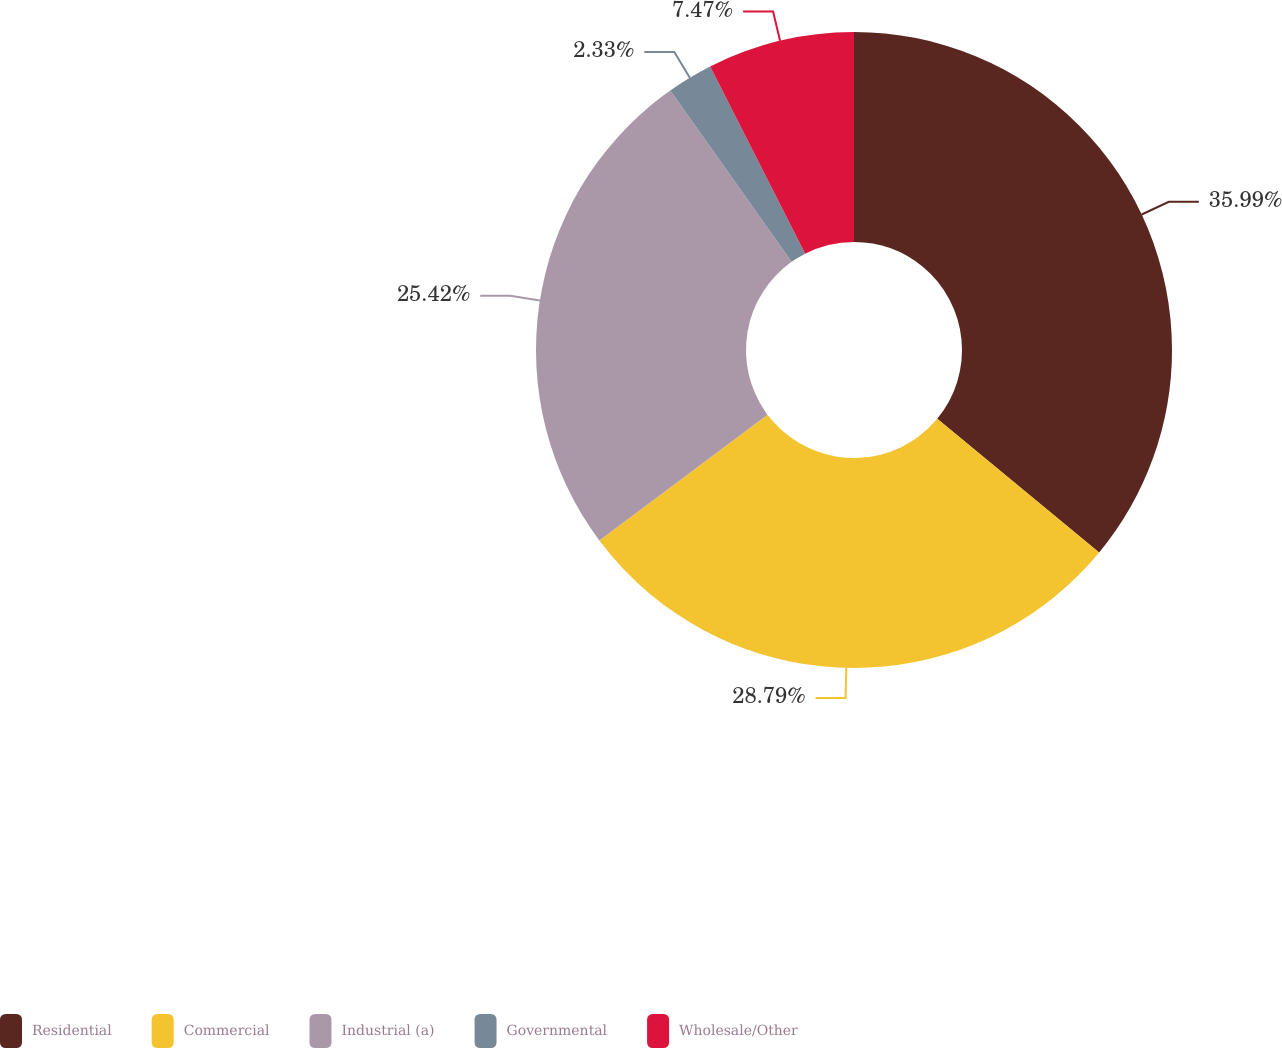<chart> <loc_0><loc_0><loc_500><loc_500><pie_chart><fcel>Residential<fcel>Commercial<fcel>Industrial (a)<fcel>Governmental<fcel>Wholesale/Other<nl><fcel>35.99%<fcel>28.79%<fcel>25.42%<fcel>2.33%<fcel>7.47%<nl></chart> 